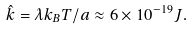Convert formula to latex. <formula><loc_0><loc_0><loc_500><loc_500>\hat { k } = \lambda k _ { B } T / a \approx 6 \times 1 0 ^ { - 1 9 } J .</formula> 